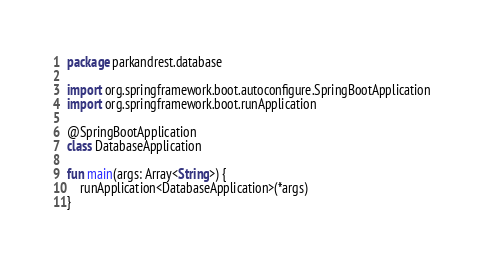Convert code to text. <code><loc_0><loc_0><loc_500><loc_500><_Kotlin_>package parkandrest.database

import org.springframework.boot.autoconfigure.SpringBootApplication
import org.springframework.boot.runApplication

@SpringBootApplication
class DatabaseApplication

fun main(args: Array<String>) {
    runApplication<DatabaseApplication>(*args)
}
</code> 